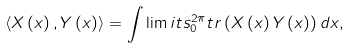<formula> <loc_0><loc_0><loc_500><loc_500>\left \langle X \left ( x \right ) , Y \left ( x \right ) \right \rangle = \int \lim i t s _ { 0 } ^ { 2 \pi } t r \left ( X \left ( x \right ) Y \left ( x \right ) \right ) d x ,</formula> 